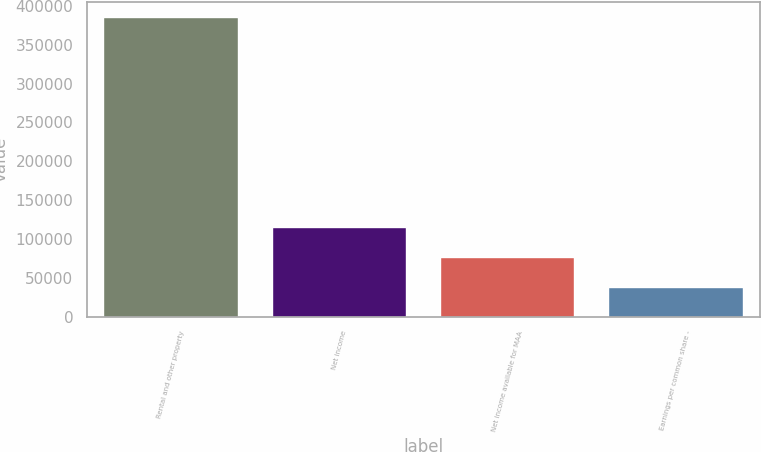Convert chart. <chart><loc_0><loc_0><loc_500><loc_500><bar_chart><fcel>Rental and other property<fcel>Net income<fcel>Net income available for MAA<fcel>Earnings per common share -<nl><fcel>386017<fcel>115805<fcel>77203.7<fcel>38602.1<nl></chart> 